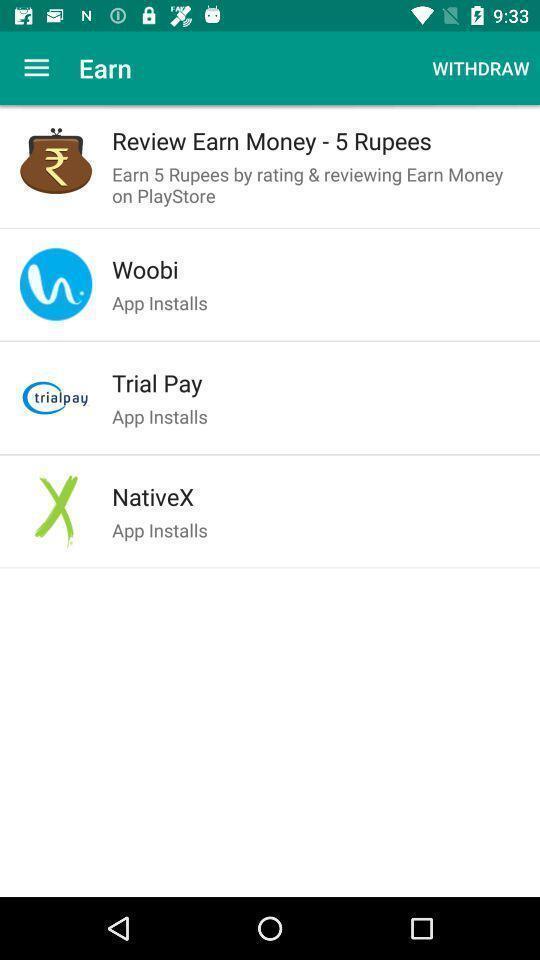Give me a narrative description of this picture. Screen displaying the list of apps. 